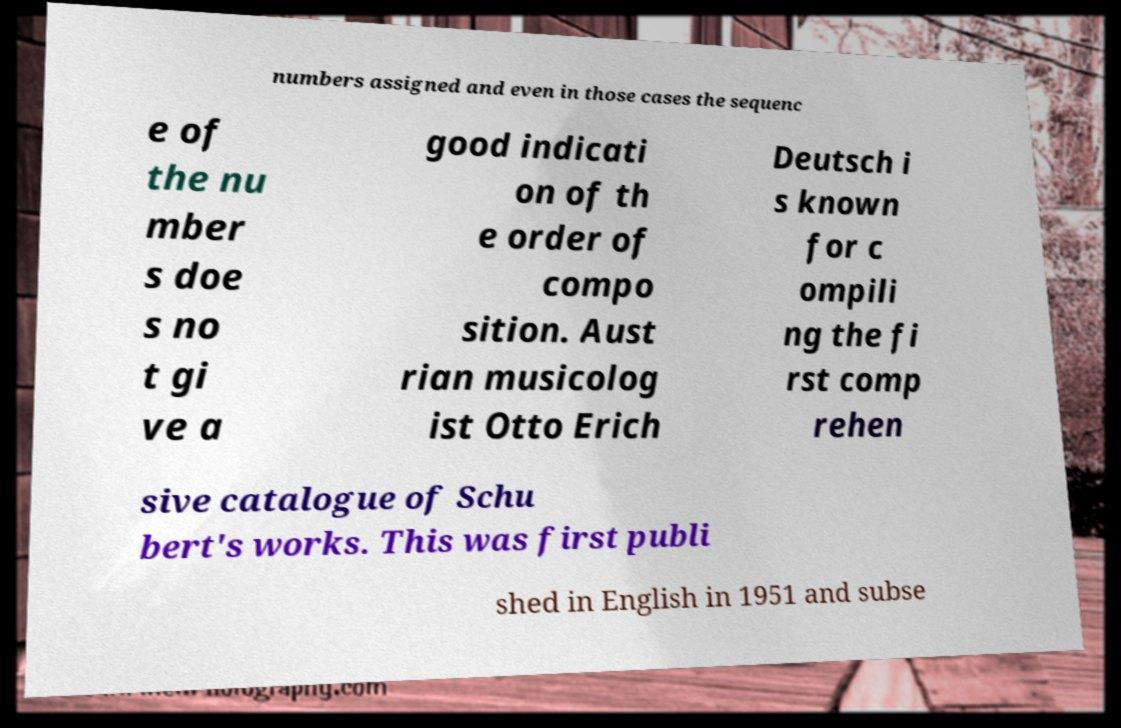There's text embedded in this image that I need extracted. Can you transcribe it verbatim? numbers assigned and even in those cases the sequenc e of the nu mber s doe s no t gi ve a good indicati on of th e order of compo sition. Aust rian musicolog ist Otto Erich Deutsch i s known for c ompili ng the fi rst comp rehen sive catalogue of Schu bert's works. This was first publi shed in English in 1951 and subse 